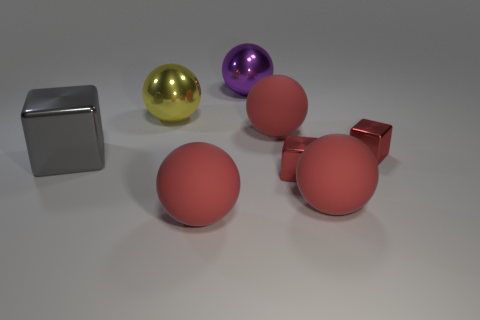Are there any brown cylinders that have the same size as the purple sphere?
Provide a short and direct response. No. There is a big ball that is left of the purple metal thing and behind the gray metal object; what is its material?
Offer a very short reply. Metal. What number of metal objects are either big blue cubes or red objects?
Provide a succinct answer. 2. There is a large purple thing that is made of the same material as the yellow object; what is its shape?
Provide a short and direct response. Sphere. What number of big things are on the right side of the large yellow ball and in front of the large yellow metal ball?
Make the answer very short. 3. What is the size of the red ball behind the big gray thing?
Provide a succinct answer. Large. What number of other objects are there of the same color as the large metal block?
Provide a succinct answer. 0. The yellow thing right of the big gray metallic block that is in front of the purple metallic ball is made of what material?
Give a very brief answer. Metal. Do the large shiny ball that is in front of the big purple metal thing and the large metallic cube have the same color?
Give a very brief answer. No. Is there any other thing that is the same material as the purple thing?
Your response must be concise. Yes. 